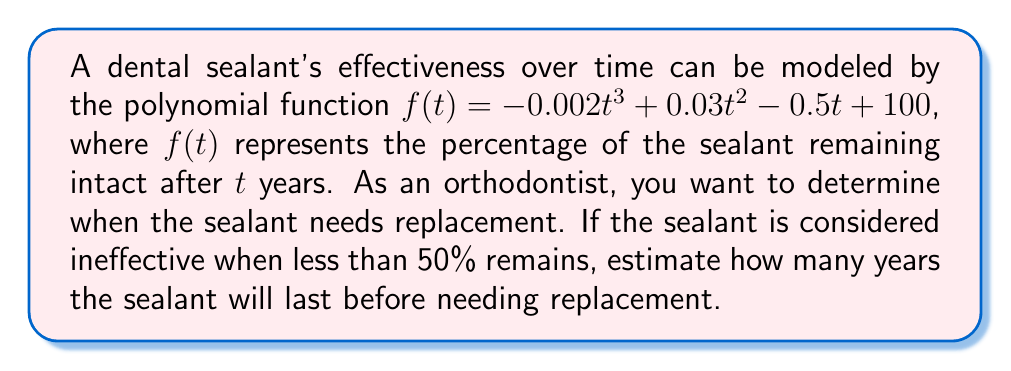Solve this math problem. To solve this problem, we need to find the value of $t$ when $f(t) = 50$. This involves the following steps:

1) Set up the equation:
   $50 = -0.002t^3 + 0.03t^2 - 0.5t + 100$

2) Rearrange the equation to standard form:
   $0.002t^3 - 0.03t^2 + 0.5t - 50 = 0$

3) This cubic equation is difficult to solve algebraically. We can use a graphing calculator or computer software to find the solution. Alternatively, we can estimate the solution using the following method:

4) Create a table of values:

   $t$ | $f(t)$
   0   | 100
   5   | 87.5
   10  | 70
   15  | 48.75

5) We can see that the value of $f(t)$ drops below 50 between $t = 10$ and $t = 15$.

6) Using linear interpolation between these points:

   At $t = 10$, $f(10) = 70$
   At $t = 15$, $f(15) = 48.75$

   The rate of change is $(48.75 - 70) / (15 - 10) = -4.25$ per year

7) To reach 50 from 70, we need to decrease by 20.
   Time needed = $20 / 4.25 \approx 4.71$ years

8) Therefore, the estimated time when $f(t) = 50$ is $10 + 4.71 = 14.71$ years.
Answer: The dental sealant will last approximately 14.7 years before needing replacement. 